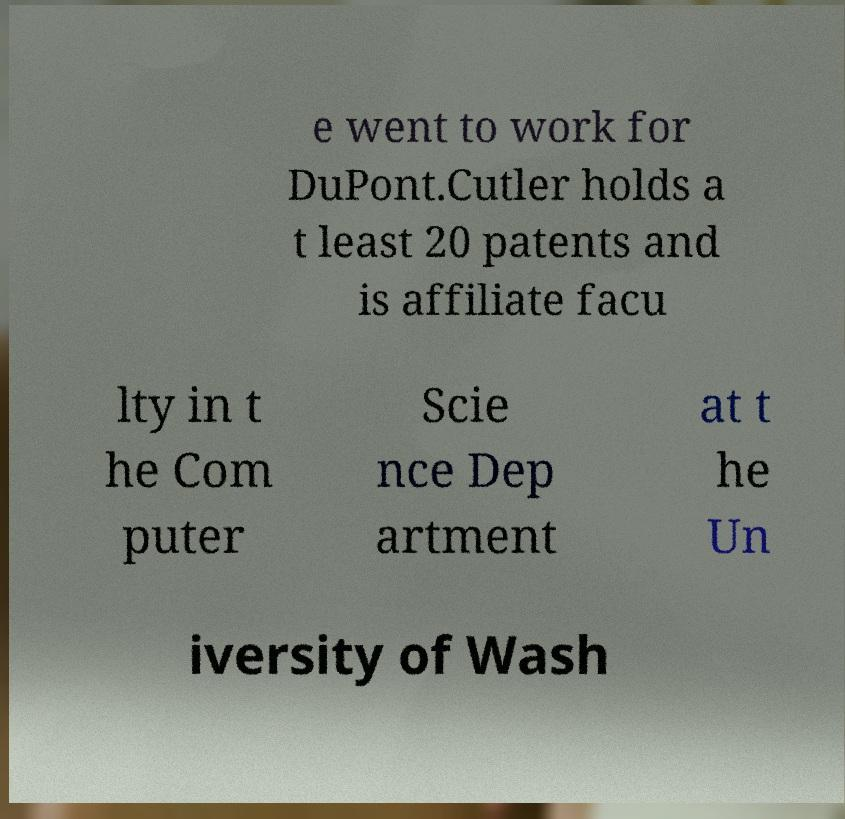Could you extract and type out the text from this image? e went to work for DuPont.Cutler holds a t least 20 patents and is affiliate facu lty in t he Com puter Scie nce Dep artment at t he Un iversity of Wash 